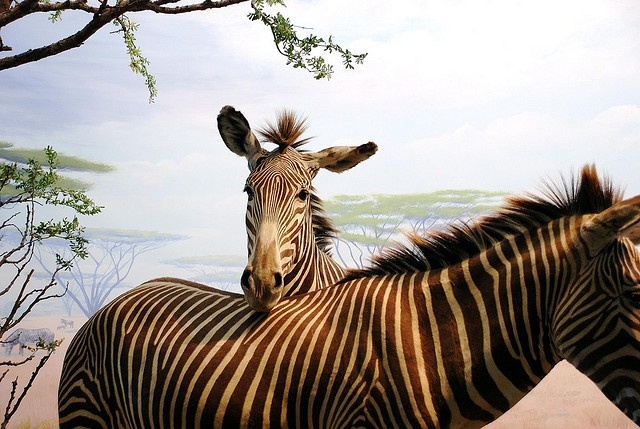Describe the objects in this image and their specific colors. I can see zebra in black, maroon, and brown tones, zebra in black, white, maroon, and tan tones, and zebra in black, darkgray, and lightgray tones in this image. 